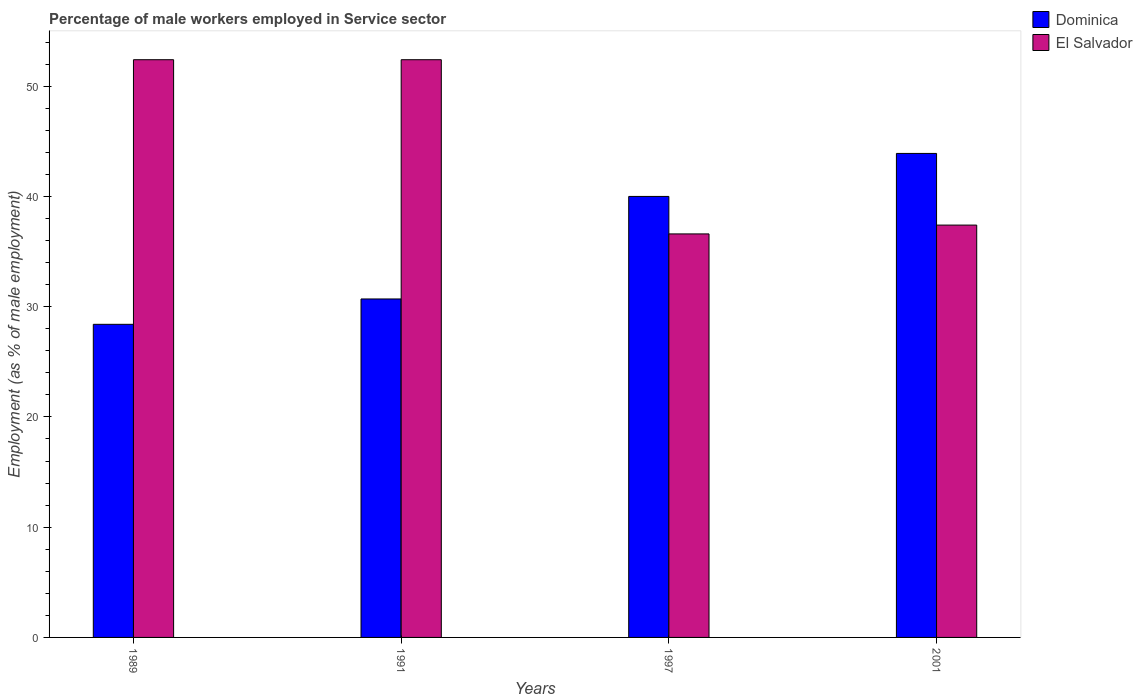How many different coloured bars are there?
Ensure brevity in your answer.  2. How many bars are there on the 1st tick from the left?
Ensure brevity in your answer.  2. In how many cases, is the number of bars for a given year not equal to the number of legend labels?
Offer a very short reply. 0. What is the percentage of male workers employed in Service sector in El Salvador in 1997?
Offer a terse response. 36.6. Across all years, what is the maximum percentage of male workers employed in Service sector in Dominica?
Your answer should be very brief. 43.9. Across all years, what is the minimum percentage of male workers employed in Service sector in El Salvador?
Offer a terse response. 36.6. In which year was the percentage of male workers employed in Service sector in Dominica maximum?
Offer a very short reply. 2001. In which year was the percentage of male workers employed in Service sector in El Salvador minimum?
Your answer should be very brief. 1997. What is the total percentage of male workers employed in Service sector in Dominica in the graph?
Make the answer very short. 143. What is the difference between the percentage of male workers employed in Service sector in Dominica in 1997 and the percentage of male workers employed in Service sector in El Salvador in 2001?
Your answer should be compact. 2.6. What is the average percentage of male workers employed in Service sector in El Salvador per year?
Your answer should be compact. 44.7. In the year 1991, what is the difference between the percentage of male workers employed in Service sector in Dominica and percentage of male workers employed in Service sector in El Salvador?
Offer a very short reply. -21.7. In how many years, is the percentage of male workers employed in Service sector in Dominica greater than 36 %?
Provide a succinct answer. 2. What is the ratio of the percentage of male workers employed in Service sector in El Salvador in 1989 to that in 1991?
Your answer should be very brief. 1. Is the percentage of male workers employed in Service sector in Dominica in 1997 less than that in 2001?
Offer a terse response. Yes. What is the difference between the highest and the second highest percentage of male workers employed in Service sector in Dominica?
Offer a very short reply. 3.9. What is the difference between the highest and the lowest percentage of male workers employed in Service sector in Dominica?
Provide a succinct answer. 15.5. What does the 2nd bar from the left in 2001 represents?
Offer a terse response. El Salvador. What does the 2nd bar from the right in 1991 represents?
Provide a succinct answer. Dominica. How many years are there in the graph?
Your answer should be compact. 4. Are the values on the major ticks of Y-axis written in scientific E-notation?
Your response must be concise. No. Does the graph contain any zero values?
Your answer should be very brief. No. Where does the legend appear in the graph?
Keep it short and to the point. Top right. How many legend labels are there?
Provide a succinct answer. 2. How are the legend labels stacked?
Your response must be concise. Vertical. What is the title of the graph?
Your answer should be compact. Percentage of male workers employed in Service sector. What is the label or title of the X-axis?
Your answer should be compact. Years. What is the label or title of the Y-axis?
Provide a short and direct response. Employment (as % of male employment). What is the Employment (as % of male employment) in Dominica in 1989?
Provide a short and direct response. 28.4. What is the Employment (as % of male employment) in El Salvador in 1989?
Provide a succinct answer. 52.4. What is the Employment (as % of male employment) of Dominica in 1991?
Make the answer very short. 30.7. What is the Employment (as % of male employment) of El Salvador in 1991?
Ensure brevity in your answer.  52.4. What is the Employment (as % of male employment) in Dominica in 1997?
Make the answer very short. 40. What is the Employment (as % of male employment) in El Salvador in 1997?
Keep it short and to the point. 36.6. What is the Employment (as % of male employment) in Dominica in 2001?
Ensure brevity in your answer.  43.9. What is the Employment (as % of male employment) in El Salvador in 2001?
Provide a short and direct response. 37.4. Across all years, what is the maximum Employment (as % of male employment) of Dominica?
Give a very brief answer. 43.9. Across all years, what is the maximum Employment (as % of male employment) in El Salvador?
Your answer should be very brief. 52.4. Across all years, what is the minimum Employment (as % of male employment) in Dominica?
Give a very brief answer. 28.4. Across all years, what is the minimum Employment (as % of male employment) in El Salvador?
Your answer should be very brief. 36.6. What is the total Employment (as % of male employment) in Dominica in the graph?
Provide a short and direct response. 143. What is the total Employment (as % of male employment) in El Salvador in the graph?
Your answer should be very brief. 178.8. What is the difference between the Employment (as % of male employment) in Dominica in 1989 and that in 1991?
Give a very brief answer. -2.3. What is the difference between the Employment (as % of male employment) in El Salvador in 1989 and that in 1991?
Provide a short and direct response. 0. What is the difference between the Employment (as % of male employment) of El Salvador in 1989 and that in 1997?
Keep it short and to the point. 15.8. What is the difference between the Employment (as % of male employment) of Dominica in 1989 and that in 2001?
Your response must be concise. -15.5. What is the difference between the Employment (as % of male employment) of El Salvador in 1989 and that in 2001?
Your answer should be very brief. 15. What is the difference between the Employment (as % of male employment) of Dominica in 1991 and that in 1997?
Give a very brief answer. -9.3. What is the difference between the Employment (as % of male employment) in El Salvador in 1991 and that in 1997?
Offer a terse response. 15.8. What is the difference between the Employment (as % of male employment) of Dominica in 1991 and that in 2001?
Make the answer very short. -13.2. What is the difference between the Employment (as % of male employment) in Dominica in 1997 and that in 2001?
Give a very brief answer. -3.9. What is the difference between the Employment (as % of male employment) in Dominica in 1989 and the Employment (as % of male employment) in El Salvador in 1997?
Give a very brief answer. -8.2. What is the difference between the Employment (as % of male employment) of Dominica in 1989 and the Employment (as % of male employment) of El Salvador in 2001?
Keep it short and to the point. -9. What is the difference between the Employment (as % of male employment) in Dominica in 1991 and the Employment (as % of male employment) in El Salvador in 1997?
Give a very brief answer. -5.9. What is the average Employment (as % of male employment) of Dominica per year?
Make the answer very short. 35.75. What is the average Employment (as % of male employment) of El Salvador per year?
Give a very brief answer. 44.7. In the year 1989, what is the difference between the Employment (as % of male employment) in Dominica and Employment (as % of male employment) in El Salvador?
Offer a terse response. -24. In the year 1991, what is the difference between the Employment (as % of male employment) of Dominica and Employment (as % of male employment) of El Salvador?
Keep it short and to the point. -21.7. What is the ratio of the Employment (as % of male employment) of Dominica in 1989 to that in 1991?
Provide a succinct answer. 0.93. What is the ratio of the Employment (as % of male employment) in El Salvador in 1989 to that in 1991?
Ensure brevity in your answer.  1. What is the ratio of the Employment (as % of male employment) of Dominica in 1989 to that in 1997?
Your answer should be very brief. 0.71. What is the ratio of the Employment (as % of male employment) of El Salvador in 1989 to that in 1997?
Your answer should be very brief. 1.43. What is the ratio of the Employment (as % of male employment) in Dominica in 1989 to that in 2001?
Ensure brevity in your answer.  0.65. What is the ratio of the Employment (as % of male employment) of El Salvador in 1989 to that in 2001?
Provide a succinct answer. 1.4. What is the ratio of the Employment (as % of male employment) of Dominica in 1991 to that in 1997?
Offer a very short reply. 0.77. What is the ratio of the Employment (as % of male employment) of El Salvador in 1991 to that in 1997?
Your answer should be very brief. 1.43. What is the ratio of the Employment (as % of male employment) of Dominica in 1991 to that in 2001?
Ensure brevity in your answer.  0.7. What is the ratio of the Employment (as % of male employment) of El Salvador in 1991 to that in 2001?
Keep it short and to the point. 1.4. What is the ratio of the Employment (as % of male employment) of Dominica in 1997 to that in 2001?
Offer a very short reply. 0.91. What is the ratio of the Employment (as % of male employment) in El Salvador in 1997 to that in 2001?
Your answer should be very brief. 0.98. What is the difference between the highest and the second highest Employment (as % of male employment) of Dominica?
Make the answer very short. 3.9. What is the difference between the highest and the lowest Employment (as % of male employment) in El Salvador?
Your answer should be compact. 15.8. 